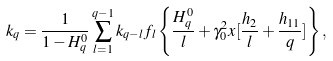<formula> <loc_0><loc_0><loc_500><loc_500>k _ { q } = \frac { 1 } { 1 - H _ { q } ^ { 0 } } \sum _ { l = 1 } ^ { q - 1 } k _ { q - l } f _ { l } \left \{ \frac { H _ { q } ^ { 0 } } { l } + \gamma _ { 0 } ^ { 2 } x [ \frac { h _ { 2 } } { l } + \frac { h _ { 1 1 } } { q } ] \right \} ,</formula> 